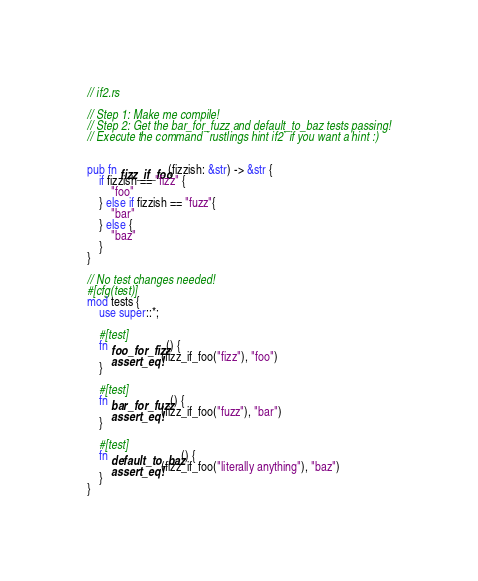<code> <loc_0><loc_0><loc_500><loc_500><_Rust_>// if2.rs

// Step 1: Make me compile!
// Step 2: Get the bar_for_fuzz and default_to_baz tests passing!
// Execute the command `rustlings hint if2` if you want a hint :)


pub fn fizz_if_foo(fizzish: &str) -> &str {
    if fizzish == "fizz" {
        "foo"
    } else if fizzish == "fuzz"{
        "bar"
    } else {
        "baz"
    }
}
 
// No test changes needed!
#[cfg(test)]
mod tests {
    use super::*;

    #[test]
    fn foo_for_fizz() {
        assert_eq!(fizz_if_foo("fizz"), "foo")
    }

    #[test]
    fn bar_for_fuzz() {
        assert_eq!(fizz_if_foo("fuzz"), "bar")
    }

    #[test]
    fn default_to_baz() {
        assert_eq!(fizz_if_foo("literally anything"), "baz")
    }
}
</code> 